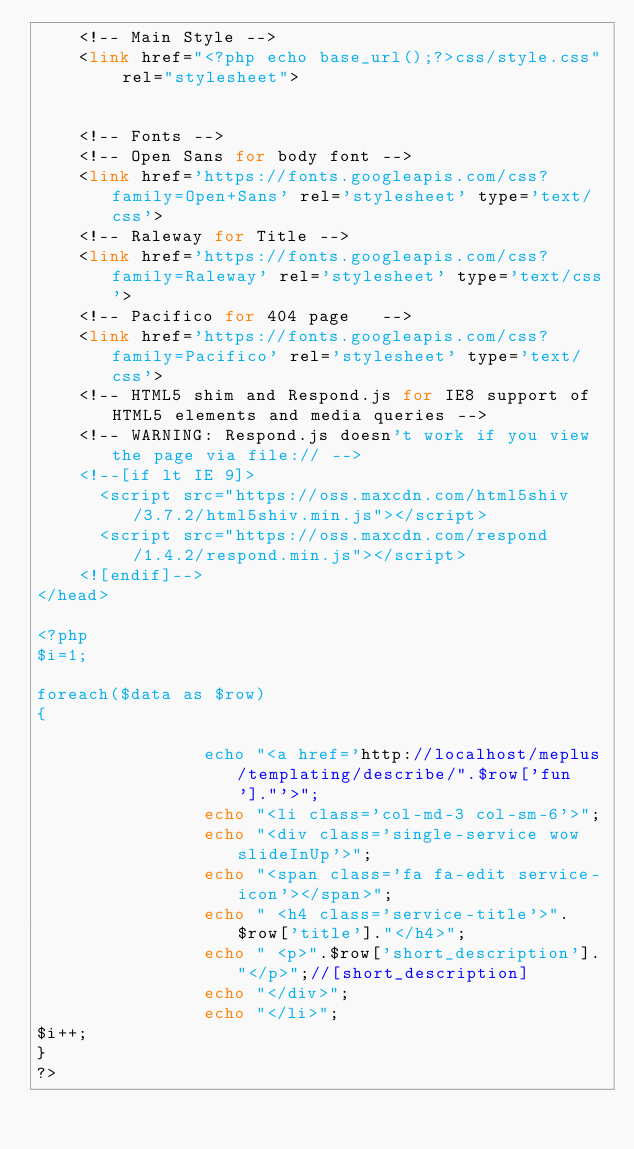<code> <loc_0><loc_0><loc_500><loc_500><_PHP_>    <!-- Main Style -->
    <link href="<?php echo base_url();?>css/style.css" rel="stylesheet">


    <!-- Fonts -->
    <!-- Open Sans for body font -->
    <link href='https://fonts.googleapis.com/css?family=Open+Sans' rel='stylesheet' type='text/css'>
    <!-- Raleway for Title -->
    <link href='https://fonts.googleapis.com/css?family=Raleway' rel='stylesheet' type='text/css'>
    <!-- Pacifico for 404 page   -->
    <link href='https://fonts.googleapis.com/css?family=Pacifico' rel='stylesheet' type='text/css'>
    <!-- HTML5 shim and Respond.js for IE8 support of HTML5 elements and media queries -->
    <!-- WARNING: Respond.js doesn't work if you view the page via file:// -->
    <!--[if lt IE 9]>
      <script src="https://oss.maxcdn.com/html5shiv/3.7.2/html5shiv.min.js"></script>
      <script src="https://oss.maxcdn.com/respond/1.4.2/respond.min.js"></script>
    <![endif]-->
</head>

<?php
$i=1;

foreach($data as $row)
{

                echo "<a href='http://localhost/meplus/templating/describe/".$row['fun']."'>";
                echo "<li class='col-md-3 col-sm-6'>";
                echo "<div class='single-service wow slideInUp'>";
                echo "<span class='fa fa-edit service-icon'></span>";
                echo " <h4 class='service-title'>".$row['title']."</h4>";
                echo " <p>".$row['short_description']."</p>";//[short_description]
                echo "</div>";
                echo "</li>";
$i++;
}
?></code> 